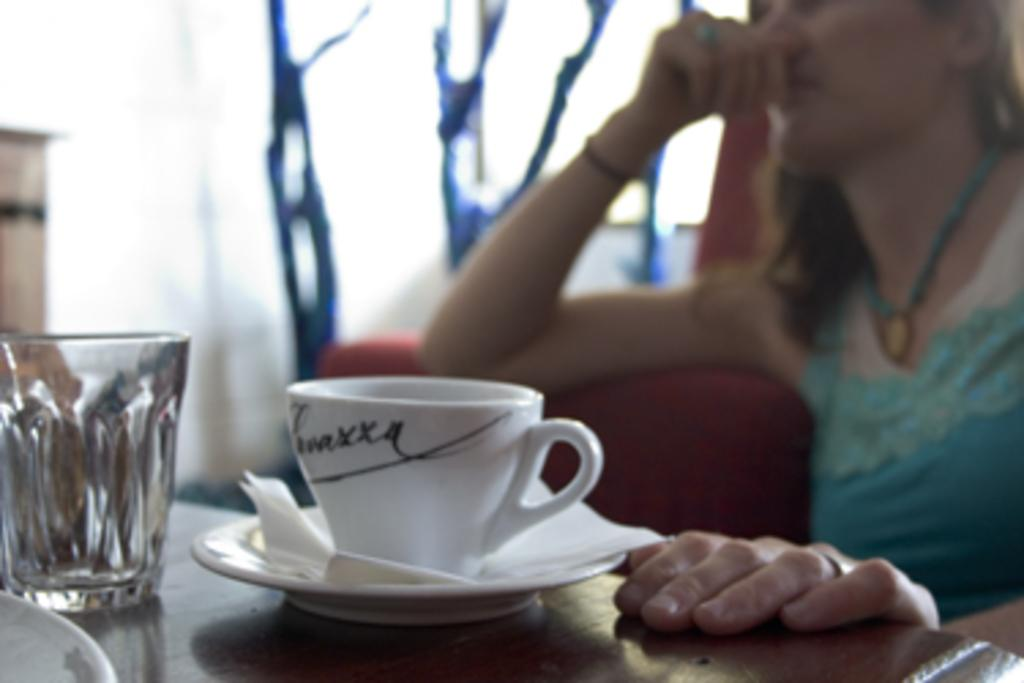What is the woman doing in the image? The woman is sitting on a sofa in the image. What can be seen on the table in the image? There is a cup, a saucer, tissues, and a glass on the table in the image. How many items are on the table in the image? There are four items on the table in the image: a cup, a saucer, tissues, and a glass. How many ducks are swimming in the spring in the image? There are no ducks or springs present in the image; it features a woman sitting on a sofa and a table with various items. 